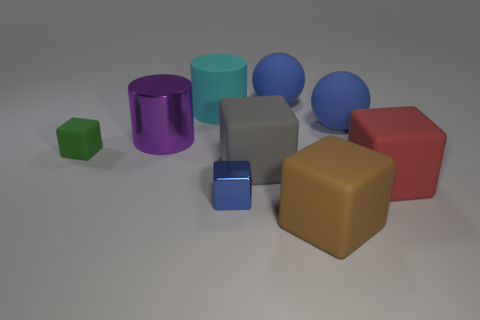Subtract all large blocks. How many blocks are left? 2 Subtract all red cubes. How many cubes are left? 4 Subtract all cylinders. How many objects are left? 7 Add 1 cyan metallic cylinders. How many objects exist? 10 Subtract all red balls. How many cyan cylinders are left? 1 Subtract all tiny metal blocks. Subtract all red rubber objects. How many objects are left? 7 Add 4 tiny blue things. How many tiny blue things are left? 5 Add 3 large rubber cubes. How many large rubber cubes exist? 6 Subtract 1 brown cubes. How many objects are left? 8 Subtract all purple cubes. Subtract all red balls. How many cubes are left? 5 